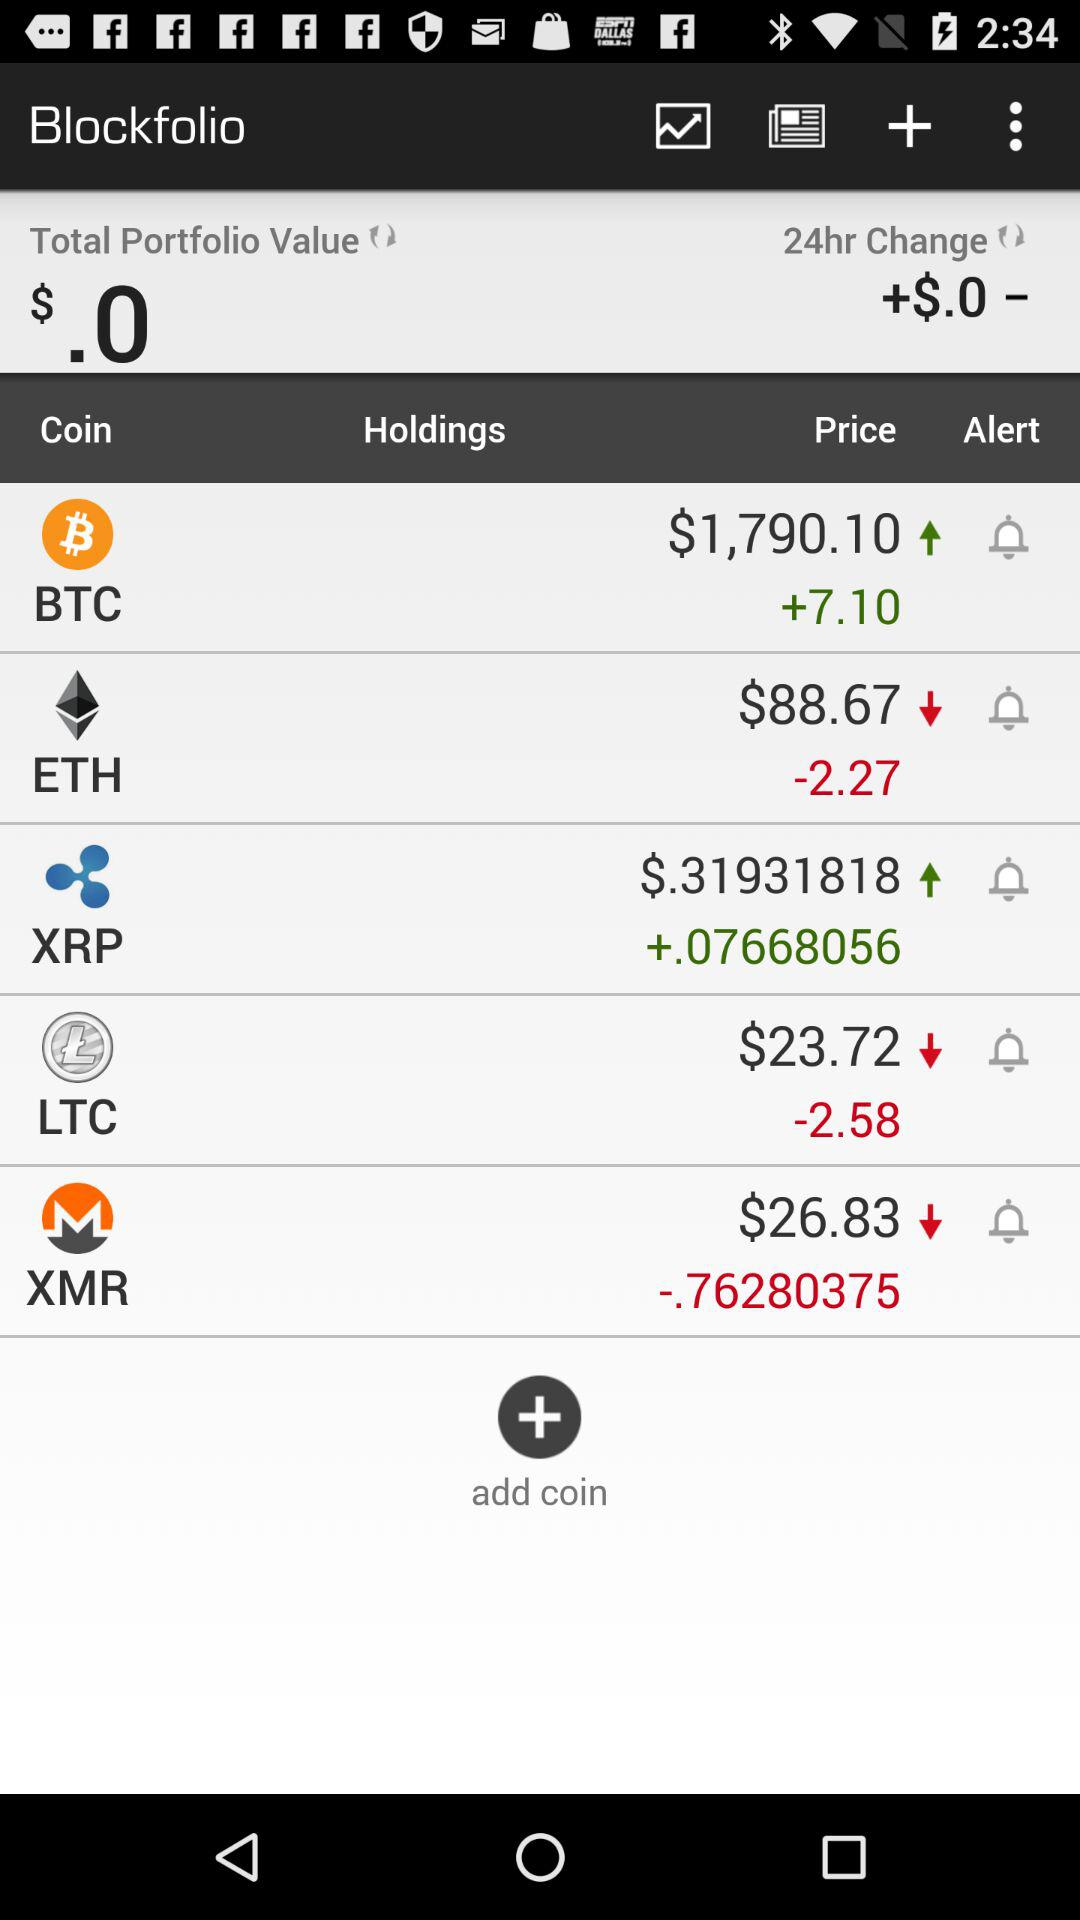What is the value of the total portfolio? The value is $0. 